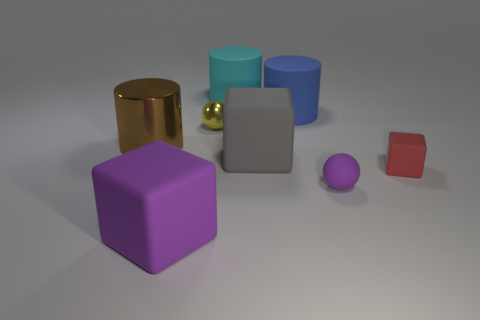Is there a red cube of the same size as the purple cube?
Your answer should be compact. No. What number of rubber blocks are there?
Provide a short and direct response. 3. There is a shiny ball; what number of big cylinders are to the right of it?
Your answer should be compact. 2. Does the tiny cube have the same material as the big purple thing?
Offer a very short reply. Yes. What number of rubber cubes are both to the right of the purple sphere and to the left of the tiny purple object?
Give a very brief answer. 0. How many other objects are there of the same color as the large metal cylinder?
Ensure brevity in your answer.  0. How many yellow things are big shiny things or tiny rubber blocks?
Your answer should be compact. 0. How big is the yellow sphere?
Provide a succinct answer. Small. How many metallic objects are tiny green blocks or gray blocks?
Provide a succinct answer. 0. Are there fewer big cyan matte cylinders than blue spheres?
Provide a succinct answer. No. 